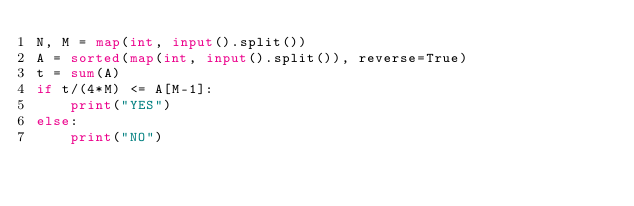Convert code to text. <code><loc_0><loc_0><loc_500><loc_500><_Python_>N, M = map(int, input().split())
A = sorted(map(int, input().split()), reverse=True)
t = sum(A)
if t/(4*M) <= A[M-1]:
    print("YES")
else:
    print("NO")
</code> 